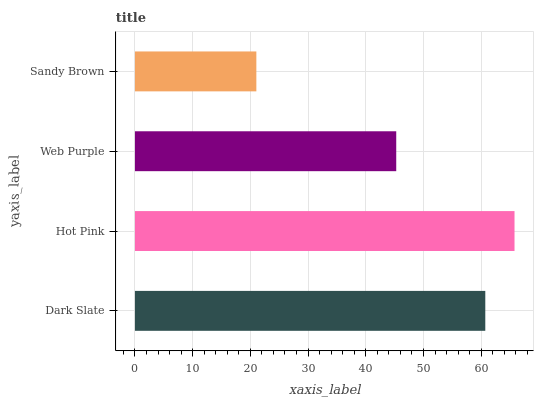Is Sandy Brown the minimum?
Answer yes or no. Yes. Is Hot Pink the maximum?
Answer yes or no. Yes. Is Web Purple the minimum?
Answer yes or no. No. Is Web Purple the maximum?
Answer yes or no. No. Is Hot Pink greater than Web Purple?
Answer yes or no. Yes. Is Web Purple less than Hot Pink?
Answer yes or no. Yes. Is Web Purple greater than Hot Pink?
Answer yes or no. No. Is Hot Pink less than Web Purple?
Answer yes or no. No. Is Dark Slate the high median?
Answer yes or no. Yes. Is Web Purple the low median?
Answer yes or no. Yes. Is Sandy Brown the high median?
Answer yes or no. No. Is Hot Pink the low median?
Answer yes or no. No. 